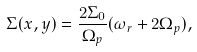Convert formula to latex. <formula><loc_0><loc_0><loc_500><loc_500>\Sigma ( x , y ) = \frac { 2 \Sigma _ { 0 } } { \Omega _ { p } } ( \omega _ { r } + 2 \Omega _ { p } ) ,</formula> 